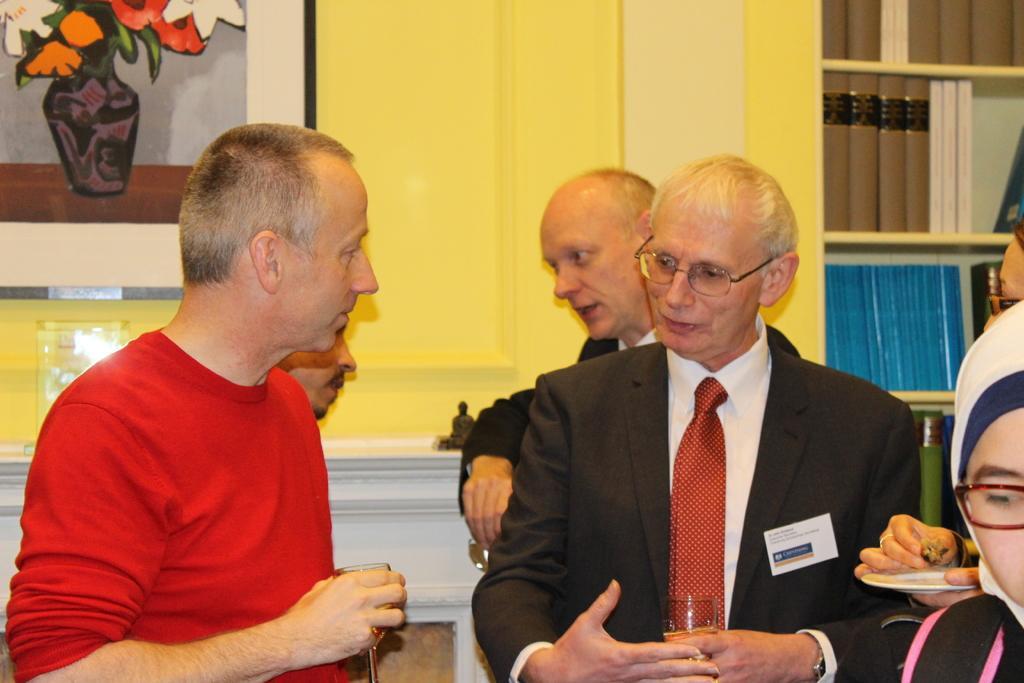Can you describe this image briefly? In this image we can see this person wearing a black blazer, spectacles and tie is holding a glass in his hands and this person wearing red T-shirt is also holding a glass in his hands. In the background, we can see a few more people. Here we can see a photo frame on the wall and books placed on the shelf. 